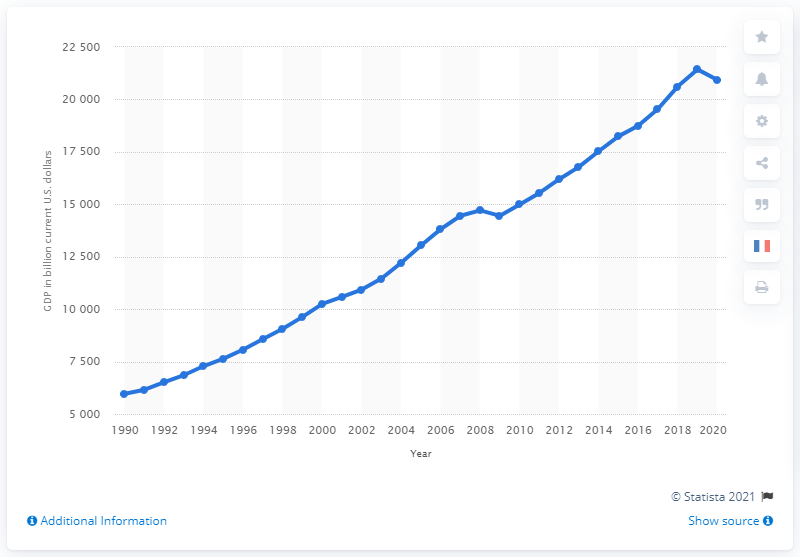Mention a couple of crucial points in this snapshot. The estimated Gross Domestic Product (GDP) of the United States in 2020 was 209,349 billion dollars. 